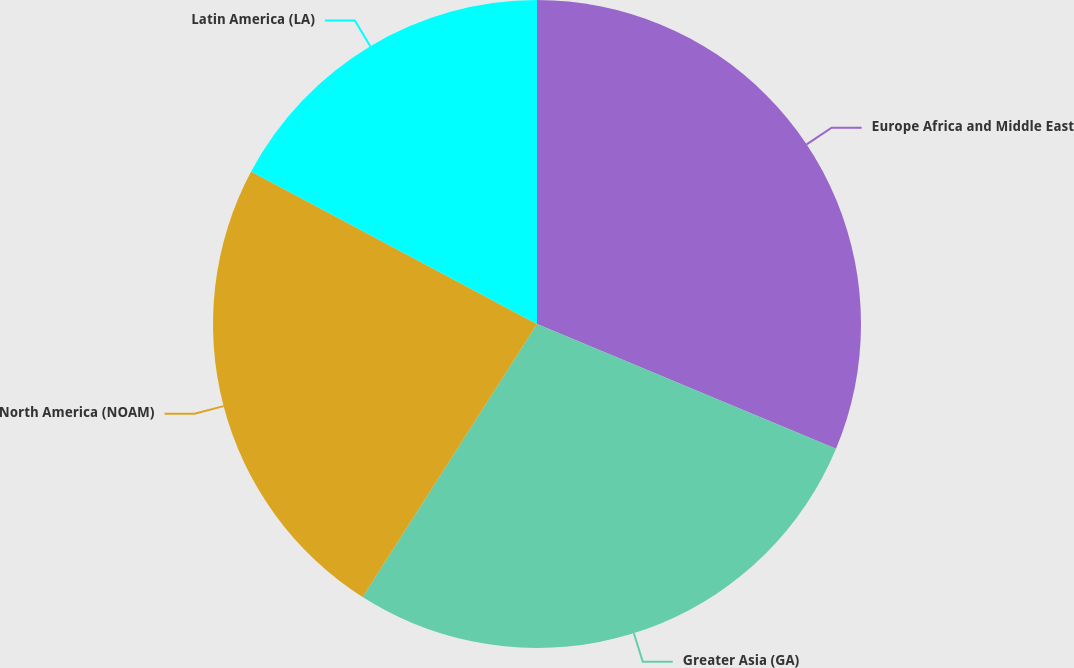<chart> <loc_0><loc_0><loc_500><loc_500><pie_chart><fcel>Europe Africa and Middle East<fcel>Greater Asia (GA)<fcel>North America (NOAM)<fcel>Latin America (LA)<nl><fcel>31.29%<fcel>27.75%<fcel>23.75%<fcel>17.2%<nl></chart> 